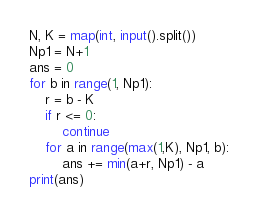Convert code to text. <code><loc_0><loc_0><loc_500><loc_500><_Python_>N, K = map(int, input().split())
Np1 = N+1
ans = 0
for b in range(1, Np1):
    r = b - K
    if r <= 0:
        continue
    for a in range(max(1,K), Np1, b):
        ans += min(a+r, Np1) - a
print(ans)</code> 